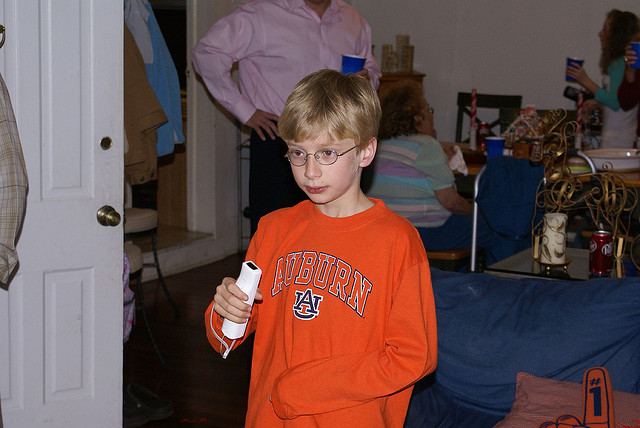<image>What state is on the mans sweater? It is unclear what state is on the man's sweater. It could be Alabama or Auburn. What state is on the mans sweater? There is no state shown on the man's sweater. 